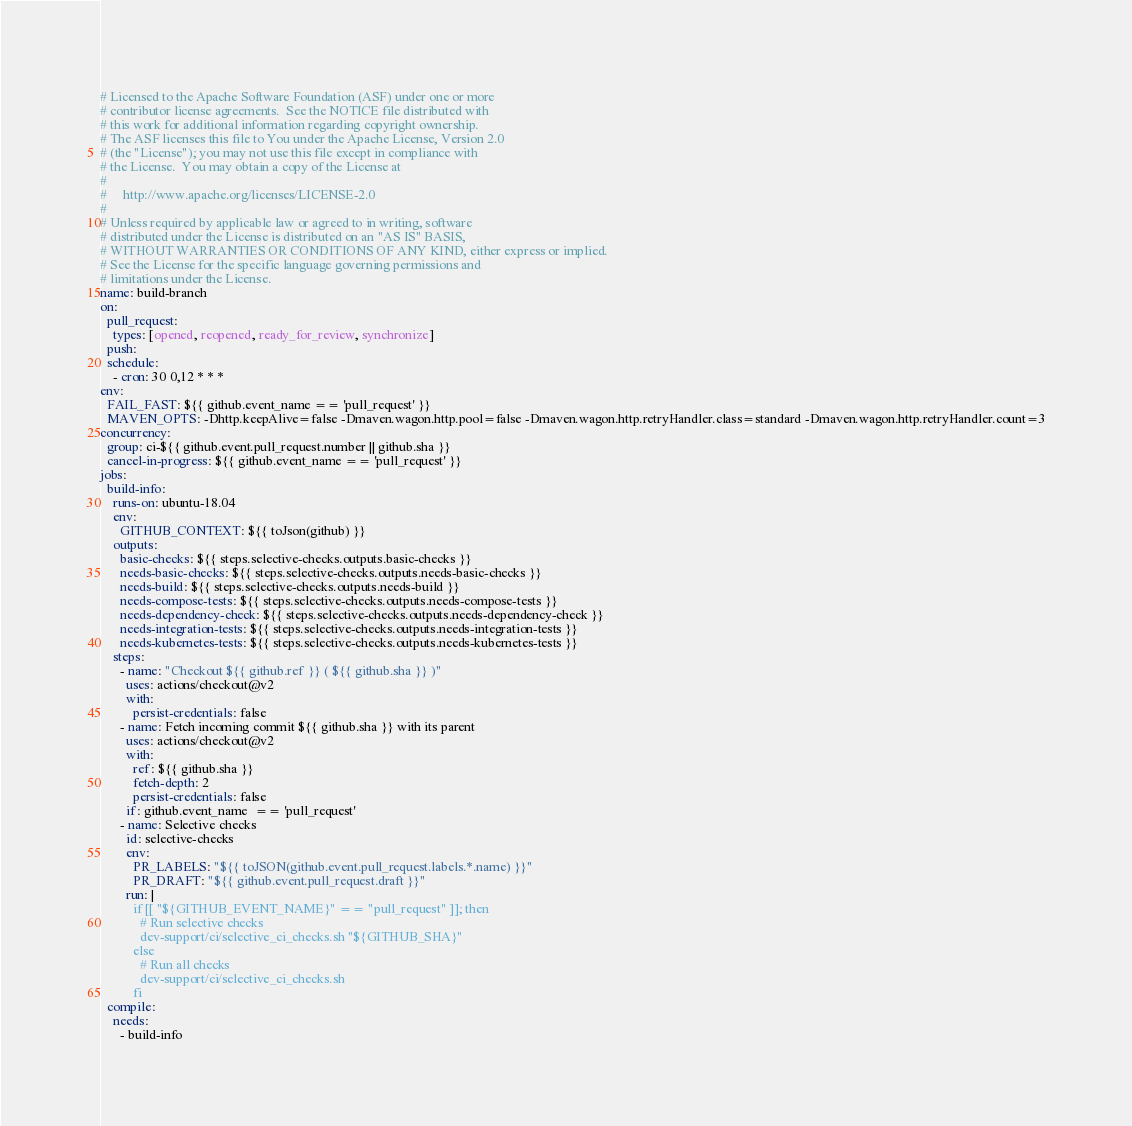Convert code to text. <code><loc_0><loc_0><loc_500><loc_500><_YAML_># Licensed to the Apache Software Foundation (ASF) under one or more
# contributor license agreements.  See the NOTICE file distributed with
# this work for additional information regarding copyright ownership.
# The ASF licenses this file to You under the Apache License, Version 2.0
# (the "License"); you may not use this file except in compliance with
# the License.  You may obtain a copy of the License at
#
#     http://www.apache.org/licenses/LICENSE-2.0
#
# Unless required by applicable law or agreed to in writing, software
# distributed under the License is distributed on an "AS IS" BASIS,
# WITHOUT WARRANTIES OR CONDITIONS OF ANY KIND, either express or implied.
# See the License for the specific language governing permissions and
# limitations under the License.
name: build-branch
on:
  pull_request:
    types: [opened, reopened, ready_for_review, synchronize]
  push:
  schedule:
    - cron: 30 0,12 * * *
env:
  FAIL_FAST: ${{ github.event_name == 'pull_request' }}
  MAVEN_OPTS: -Dhttp.keepAlive=false -Dmaven.wagon.http.pool=false -Dmaven.wagon.http.retryHandler.class=standard -Dmaven.wagon.http.retryHandler.count=3
concurrency:
  group: ci-${{ github.event.pull_request.number || github.sha }}
  cancel-in-progress: ${{ github.event_name == 'pull_request' }}
jobs:
  build-info:
    runs-on: ubuntu-18.04
    env:
      GITHUB_CONTEXT: ${{ toJson(github) }}
    outputs:
      basic-checks: ${{ steps.selective-checks.outputs.basic-checks }}
      needs-basic-checks: ${{ steps.selective-checks.outputs.needs-basic-checks }}
      needs-build: ${{ steps.selective-checks.outputs.needs-build }}
      needs-compose-tests: ${{ steps.selective-checks.outputs.needs-compose-tests }}
      needs-dependency-check: ${{ steps.selective-checks.outputs.needs-dependency-check }}
      needs-integration-tests: ${{ steps.selective-checks.outputs.needs-integration-tests }}
      needs-kubernetes-tests: ${{ steps.selective-checks.outputs.needs-kubernetes-tests }}
    steps:
      - name: "Checkout ${{ github.ref }} ( ${{ github.sha }} )"
        uses: actions/checkout@v2
        with:
          persist-credentials: false
      - name: Fetch incoming commit ${{ github.sha }} with its parent
        uses: actions/checkout@v2
        with:
          ref: ${{ github.sha }}
          fetch-depth: 2
          persist-credentials: false
        if: github.event_name  == 'pull_request'
      - name: Selective checks
        id: selective-checks
        env:
          PR_LABELS: "${{ toJSON(github.event.pull_request.labels.*.name) }}"
          PR_DRAFT: "${{ github.event.pull_request.draft }}"
        run: |
          if [[ "${GITHUB_EVENT_NAME}" == "pull_request" ]]; then
            # Run selective checks
            dev-support/ci/selective_ci_checks.sh "${GITHUB_SHA}"
          else
            # Run all checks
            dev-support/ci/selective_ci_checks.sh
          fi
  compile:
    needs:
      - build-info</code> 